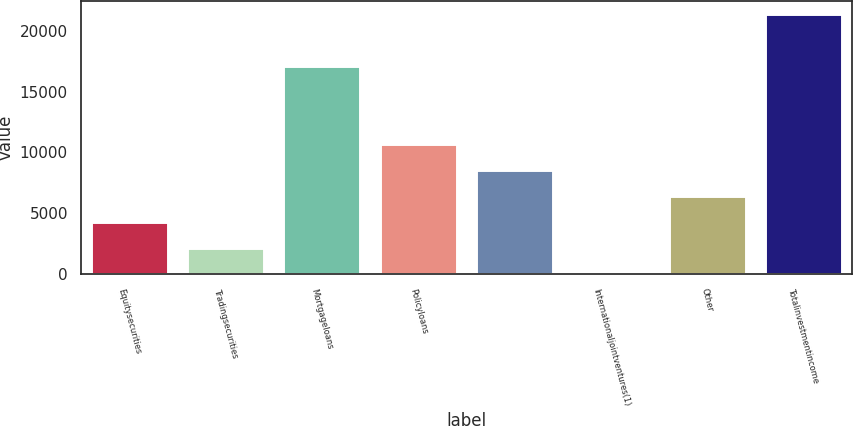Convert chart to OTSL. <chart><loc_0><loc_0><loc_500><loc_500><bar_chart><fcel>Equitysecurities<fcel>Tradingsecurities<fcel>Mortgageloans<fcel>Policyloans<fcel>Unnamed: 4<fcel>Internationaljointventures(1)<fcel>Other<fcel>Totalinvestmentincome<nl><fcel>4284.4<fcel>2150.7<fcel>17086.6<fcel>10685.5<fcel>8551.8<fcel>17<fcel>6418.1<fcel>21354<nl></chart> 